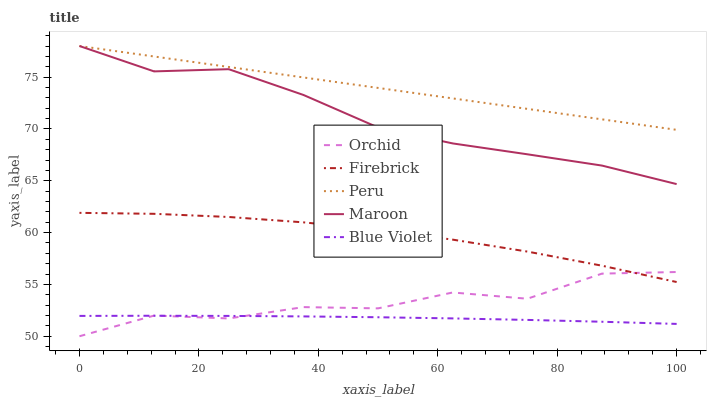Does Blue Violet have the minimum area under the curve?
Answer yes or no. Yes. Does Peru have the maximum area under the curve?
Answer yes or no. Yes. Does Firebrick have the minimum area under the curve?
Answer yes or no. No. Does Firebrick have the maximum area under the curve?
Answer yes or no. No. Is Peru the smoothest?
Answer yes or no. Yes. Is Orchid the roughest?
Answer yes or no. Yes. Is Firebrick the smoothest?
Answer yes or no. No. Is Firebrick the roughest?
Answer yes or no. No. Does Orchid have the lowest value?
Answer yes or no. Yes. Does Firebrick have the lowest value?
Answer yes or no. No. Does Peru have the highest value?
Answer yes or no. Yes. Does Firebrick have the highest value?
Answer yes or no. No. Is Blue Violet less than Peru?
Answer yes or no. Yes. Is Maroon greater than Blue Violet?
Answer yes or no. Yes. Does Maroon intersect Peru?
Answer yes or no. Yes. Is Maroon less than Peru?
Answer yes or no. No. Is Maroon greater than Peru?
Answer yes or no. No. Does Blue Violet intersect Peru?
Answer yes or no. No. 